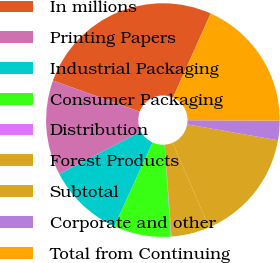Convert chart. <chart><loc_0><loc_0><loc_500><loc_500><pie_chart><fcel>In millions<fcel>Printing Papers<fcel>Industrial Packaging<fcel>Consumer Packaging<fcel>Distribution<fcel>Forest Products<fcel>Subtotal<fcel>Corporate and other<fcel>Total from Continuing<nl><fcel>26.21%<fcel>13.14%<fcel>10.53%<fcel>7.92%<fcel>0.08%<fcel>5.3%<fcel>15.76%<fcel>2.69%<fcel>18.37%<nl></chart> 